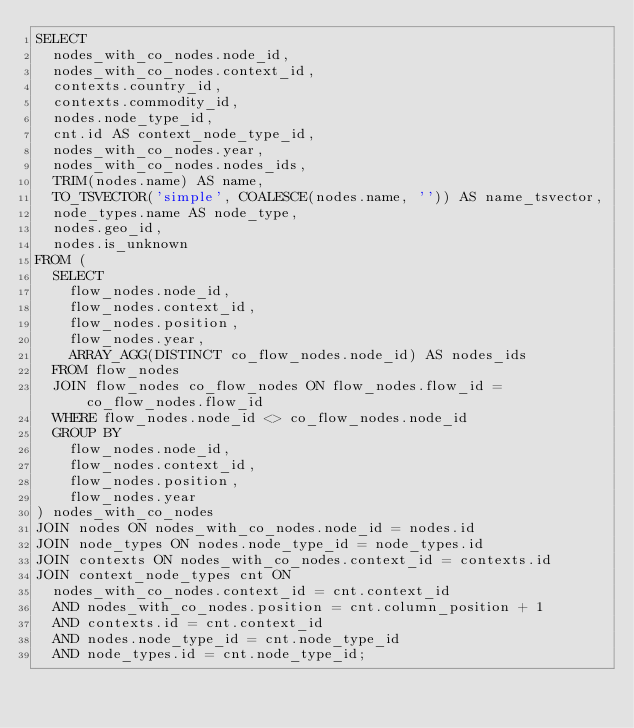Convert code to text. <code><loc_0><loc_0><loc_500><loc_500><_SQL_>SELECT
  nodes_with_co_nodes.node_id,
  nodes_with_co_nodes.context_id,
  contexts.country_id,
  contexts.commodity_id,
  nodes.node_type_id,
  cnt.id AS context_node_type_id,
  nodes_with_co_nodes.year,
  nodes_with_co_nodes.nodes_ids,
  TRIM(nodes.name) AS name,
  TO_TSVECTOR('simple', COALESCE(nodes.name, '')) AS name_tsvector,
  node_types.name AS node_type,
  nodes.geo_id,
  nodes.is_unknown
FROM (
  SELECT
    flow_nodes.node_id,
    flow_nodes.context_id,
    flow_nodes.position,
    flow_nodes.year,
    ARRAY_AGG(DISTINCT co_flow_nodes.node_id) AS nodes_ids
  FROM flow_nodes
  JOIN flow_nodes co_flow_nodes ON flow_nodes.flow_id = co_flow_nodes.flow_id
  WHERE flow_nodes.node_id <> co_flow_nodes.node_id
  GROUP BY
    flow_nodes.node_id,
    flow_nodes.context_id,
    flow_nodes.position,
    flow_nodes.year
) nodes_with_co_nodes
JOIN nodes ON nodes_with_co_nodes.node_id = nodes.id
JOIN node_types ON nodes.node_type_id = node_types.id
JOIN contexts ON nodes_with_co_nodes.context_id = contexts.id
JOIN context_node_types cnt ON
  nodes_with_co_nodes.context_id = cnt.context_id
  AND nodes_with_co_nodes.position = cnt.column_position + 1
  AND contexts.id = cnt.context_id
  AND nodes.node_type_id = cnt.node_type_id
  AND node_types.id = cnt.node_type_id;
</code> 